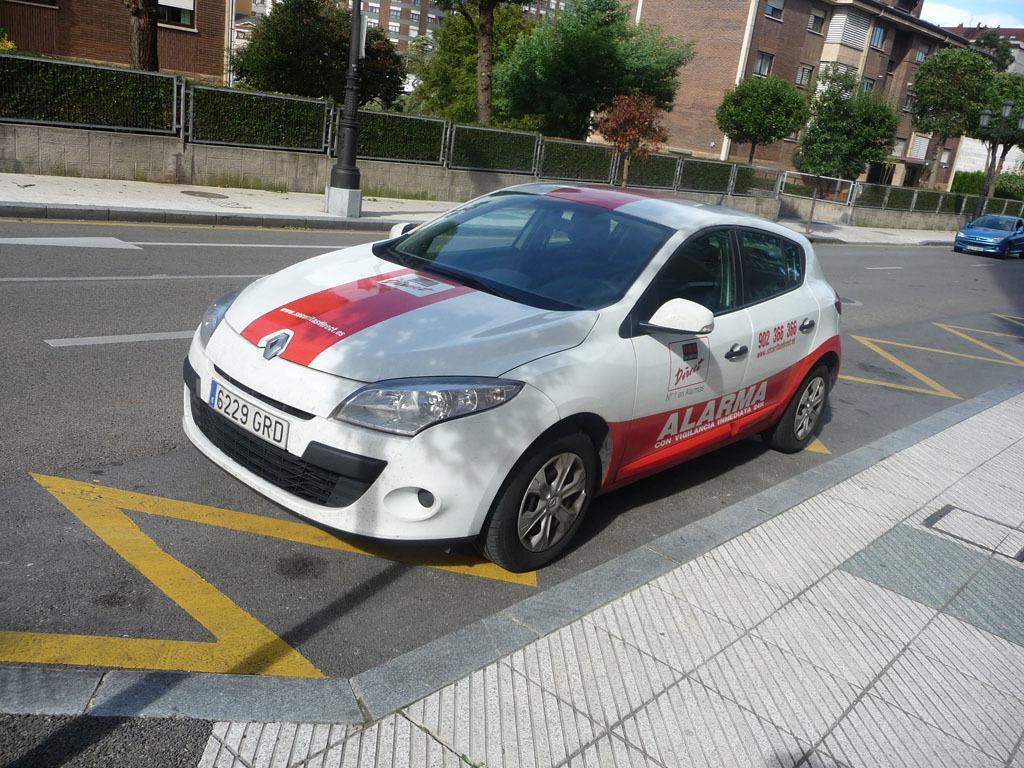In one or two sentences, can you explain what this image depicts? In this image we can see some buildings with glass windows, one pole with board, one fence near the footpath, one pole, two cars on the road, some objects are on the surface, some trees, bushes, plants and grass on the surface. At the top there is the sky. 